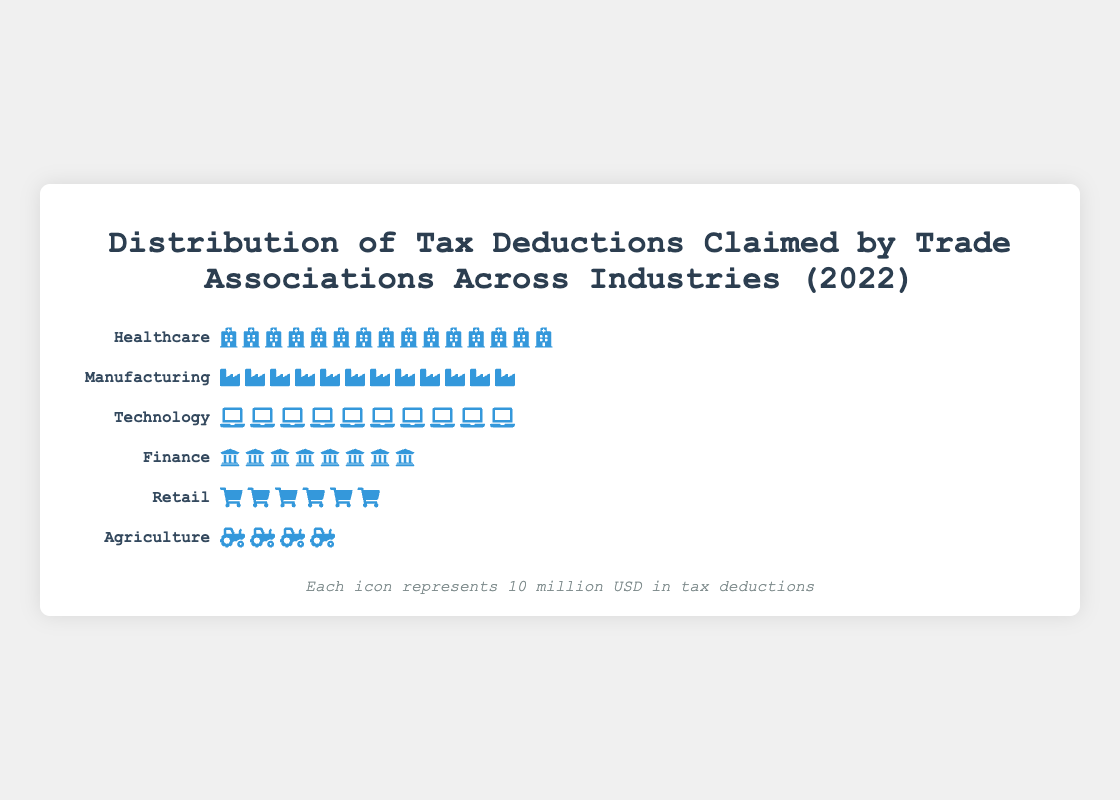What is the title of the isotype plot? The title is located at the top center of the plot. It states the context of the image.
Answer: Distribution of Tax Deductions Claimed by Trade Associations Across Industries (2022) How many icons represent the tax deductions for the Healthcare industry? Count the number of icons (hospital) for the Healthcare industry in the plot.
Answer: 15 Which industry has the highest tax deductions? Compare the total number of icons for each industry. The industry with the most icons represents the highest tax deductions.
Answer: Healthcare How much are the tax deductions for the Finance industry? Each icon represents 10 million USD. Count the number of bank (university) icons and multiply by 10 million USD. 8 icons * 10 million USD = 80 million USD.
Answer: 80 million USD Which industry has the least number of tax deductions, and how much is it? Identify the industry with the least icons and multiply the number of tractor icons by 10 million USD. 4 icons * 10 million USD = 40 million USD.
Answer: Agriculture, 40 million USD How much more in tax deductions does the Technology industry have compared to the Retail industry? Calculate the difference in the number of icons between Technology (10) and Retail (6) and multiply by 10 million USD. 4 icons * 10 million USD = 40 million USD.
Answer: 40 million USD What is the total amount of tax deductions claimed by all the industries combined? Sum the tax deductions of all industries: (150+120+100+80+60+40) million USD = 550 million USD.
Answer: 550 million USD If each icon represents 10 million USD, how many icons in total are used in the plot? Add up the total number of icons across all industries: 15 (Healthcare) + 12 (Manufacturing) + 10 (Technology) + 8 (Finance) + 6 (Retail) + 4 (Agriculture) = 55 icons.
Answer: 55 Which industry has exactly half the tax deductions of Manufacturing? Manufacturing has 120 million USD in deductions. The industry with half of that (60 million USD) is Retail.
Answer: Retail 